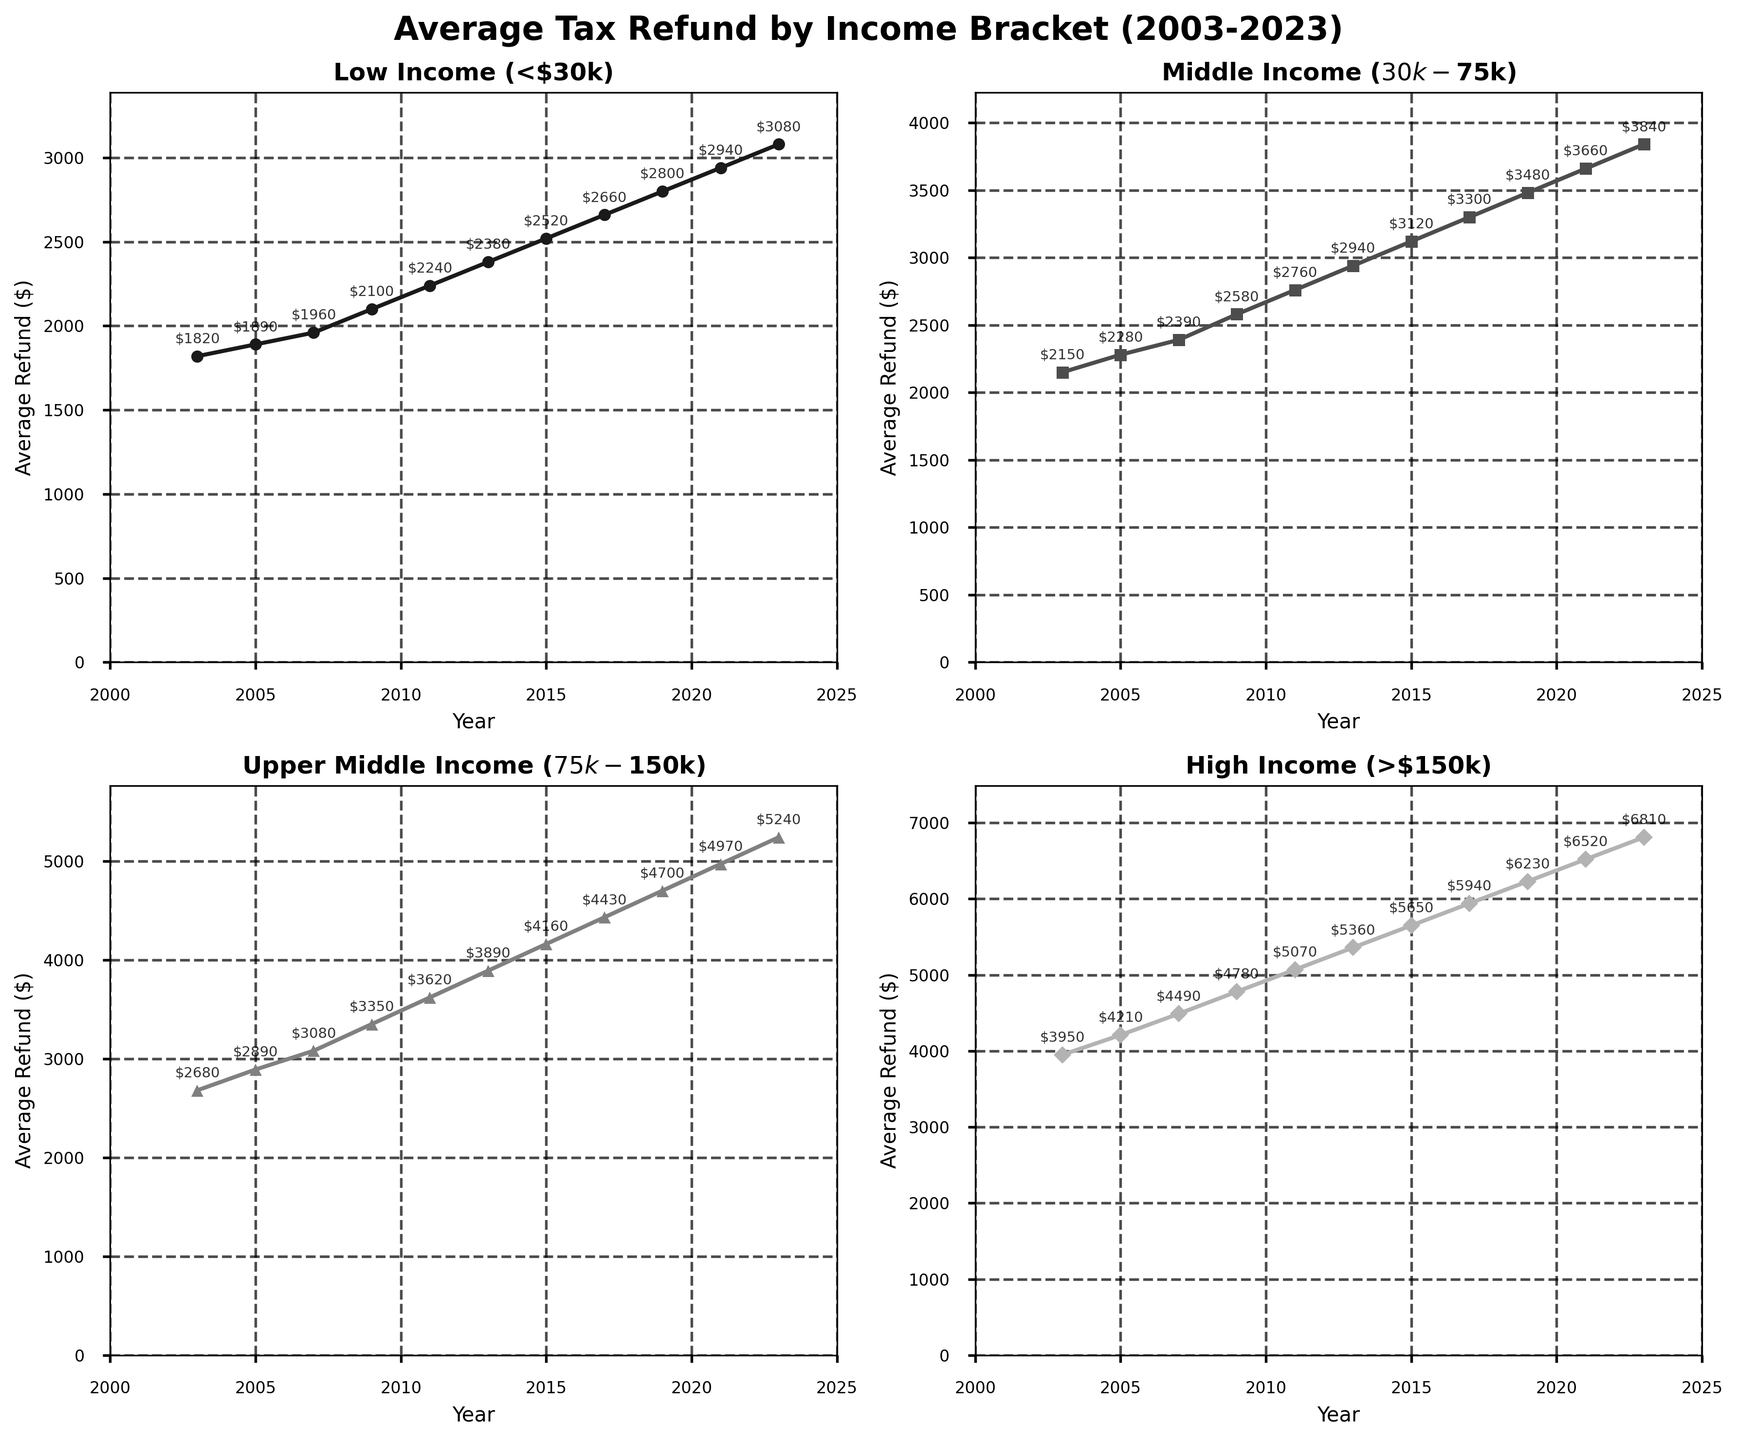What is the title of the overall figure? The title of the figure is located at the top and reads "Average Tax Refund by Income Bracket (2003-2023)".
Answer: Average Tax Refund by Income Bracket (2003-2023) How many line charts are there in the figure? The figure is composed of four separate line charts, one for each income bracket.
Answer: Four What is the average tax refund amount for the High Income bracket in 2021? Locate the High Income subplot and find the data point for the year 2021. The value is 6520.
Answer: 6520 Between which two years did the Low Income bracket see the highest increase in average tax refund? Identify the year-to-year differences in the Low Income bracket subplot. The highest increase is between 2021 and 2023, from 2940 to 3080, which is a difference of 140.
Answer: 2021 and 2023 Which income bracket had the smallest average tax refund in 2003? Compare the data points for all brackets in the year 2003. The Low Income bracket has the smallest average tax refund of 1820.
Answer: Low Income (<$30k) How much did the average tax refund for the Middle Income bracket increase from 2009 to 2019? In the Middle Income subplot, subtract the value in 2009 (2580) from the value in 2019 (3480). The increase is 900.
Answer: 900 In which year did the Upper Middle Income bracket first exceed an average tax refund of $4000? Look through the Upper Middle Income subplot and identify the year when the average refund surpasses 4000. It happens in 2017, when the refund amount is 4430.
Answer: 2017 Which income bracket shows the most consistent increase in average tax refund over the years? Observe the trend lines in each subplot. All lines show increases, but the High Income bracket has the most consistent and sharp increase over time.
Answer: High Income (>$150k) What is the difference in the average tax refund between the High Income and Low Income brackets in 2023? In 2023, the refund for High Income is 6810 and for Low Income is 3080. Subtract 3080 from 6810 to find the difference, which is 3730.
Answer: 3730 